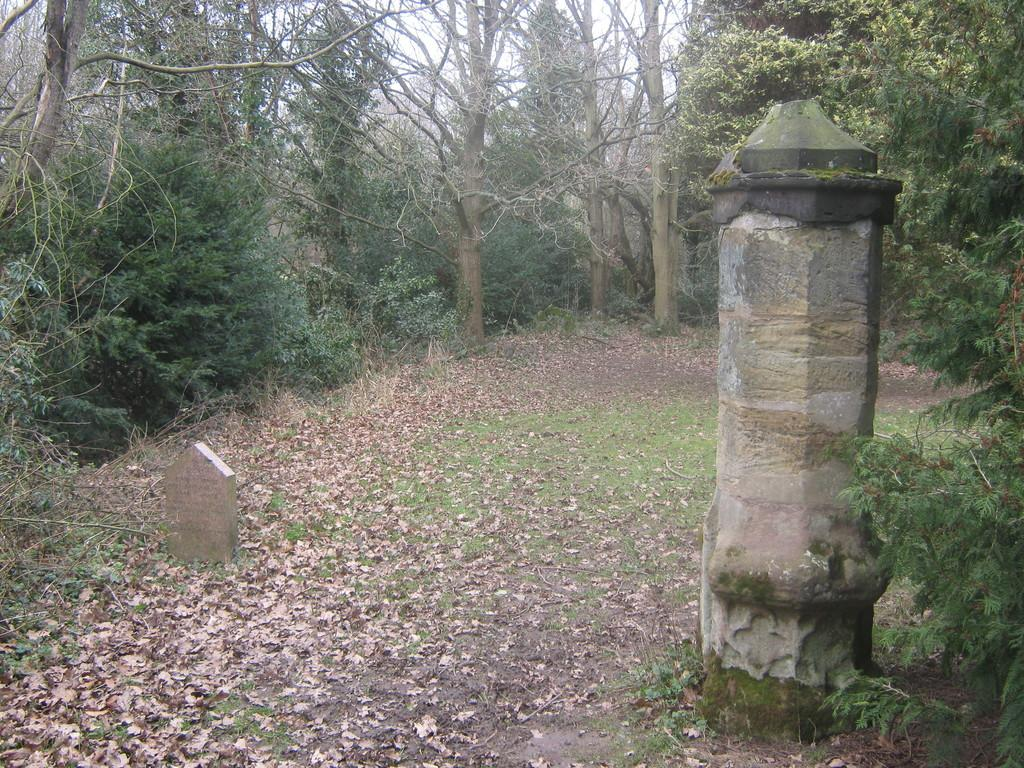What type of natural material can be seen in the image? There are dry leaves in the image. What structure is present in the image? There is a pole in the image. What type of vegetation is visible in the image? There are trees in the image. What is visible at the top of the image? The sky is visible at the top of the image. Can you tell me how many men are wearing skirts in the image? There are no men or skirts present in the image. How many visitors can be seen interacting with the trees in the image? There are no visitors present in the image; only dry leaves, a pole, trees, and the sky are visible. 